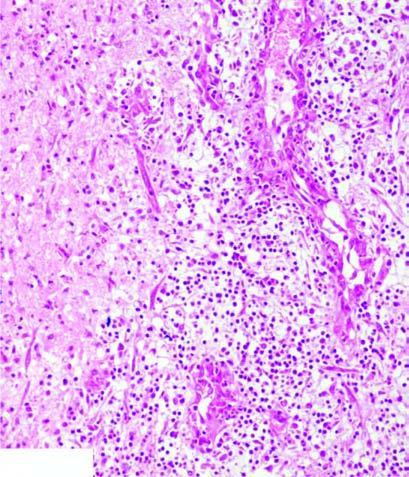what does the necrosed area on right side of the field show?
Answer the question using a single word or phrase. Cystic space containing cell debris 